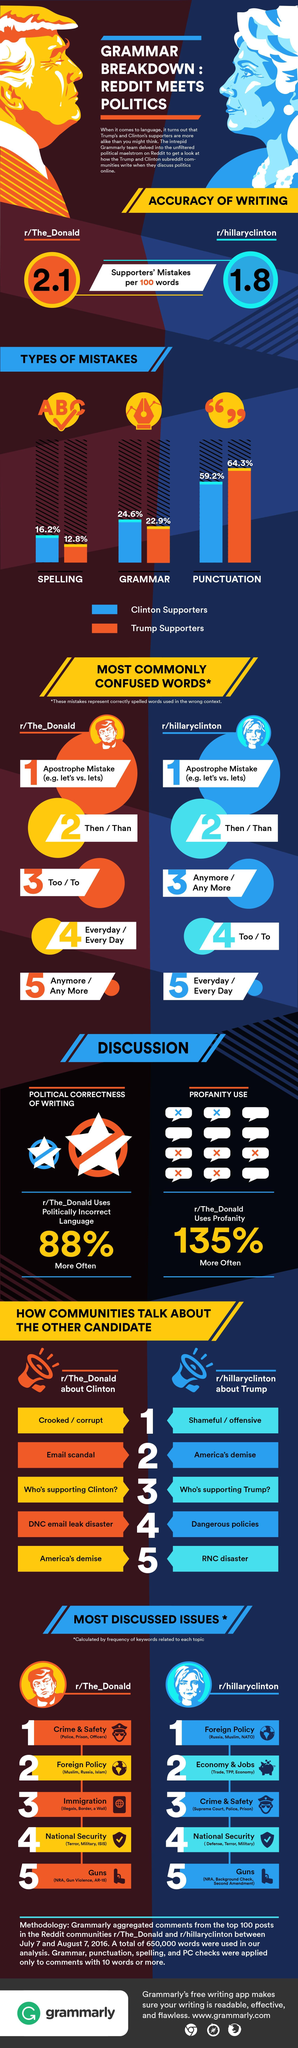What percent of Trump supporters make punctuation mistakes?
Answer the question with a short phrase. 64.3% What percent of Hillary's supporters make spelling mistakes? 16.2% Whose supporters' mistakes are more per 100 words? Trump 